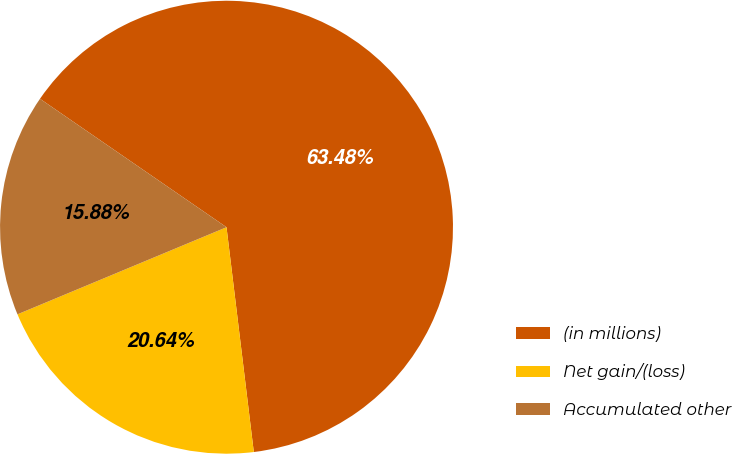Convert chart to OTSL. <chart><loc_0><loc_0><loc_500><loc_500><pie_chart><fcel>(in millions)<fcel>Net gain/(loss)<fcel>Accumulated other<nl><fcel>63.48%<fcel>20.64%<fcel>15.88%<nl></chart> 